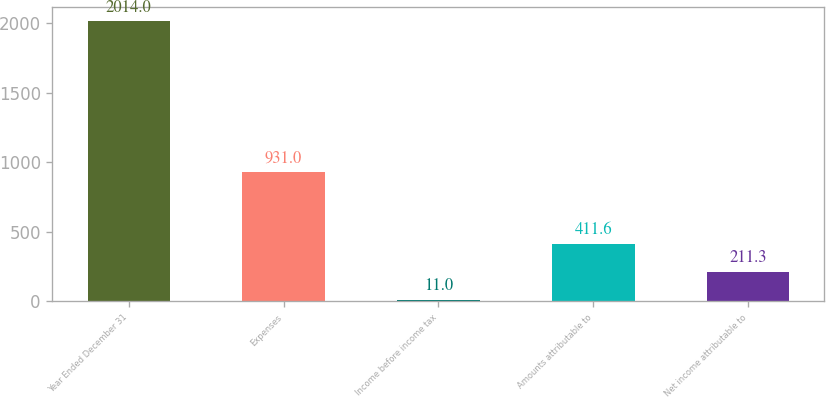<chart> <loc_0><loc_0><loc_500><loc_500><bar_chart><fcel>Year Ended December 31<fcel>Expenses<fcel>Income before income tax<fcel>Amounts attributable to<fcel>Net income attributable to<nl><fcel>2014<fcel>931<fcel>11<fcel>411.6<fcel>211.3<nl></chart> 